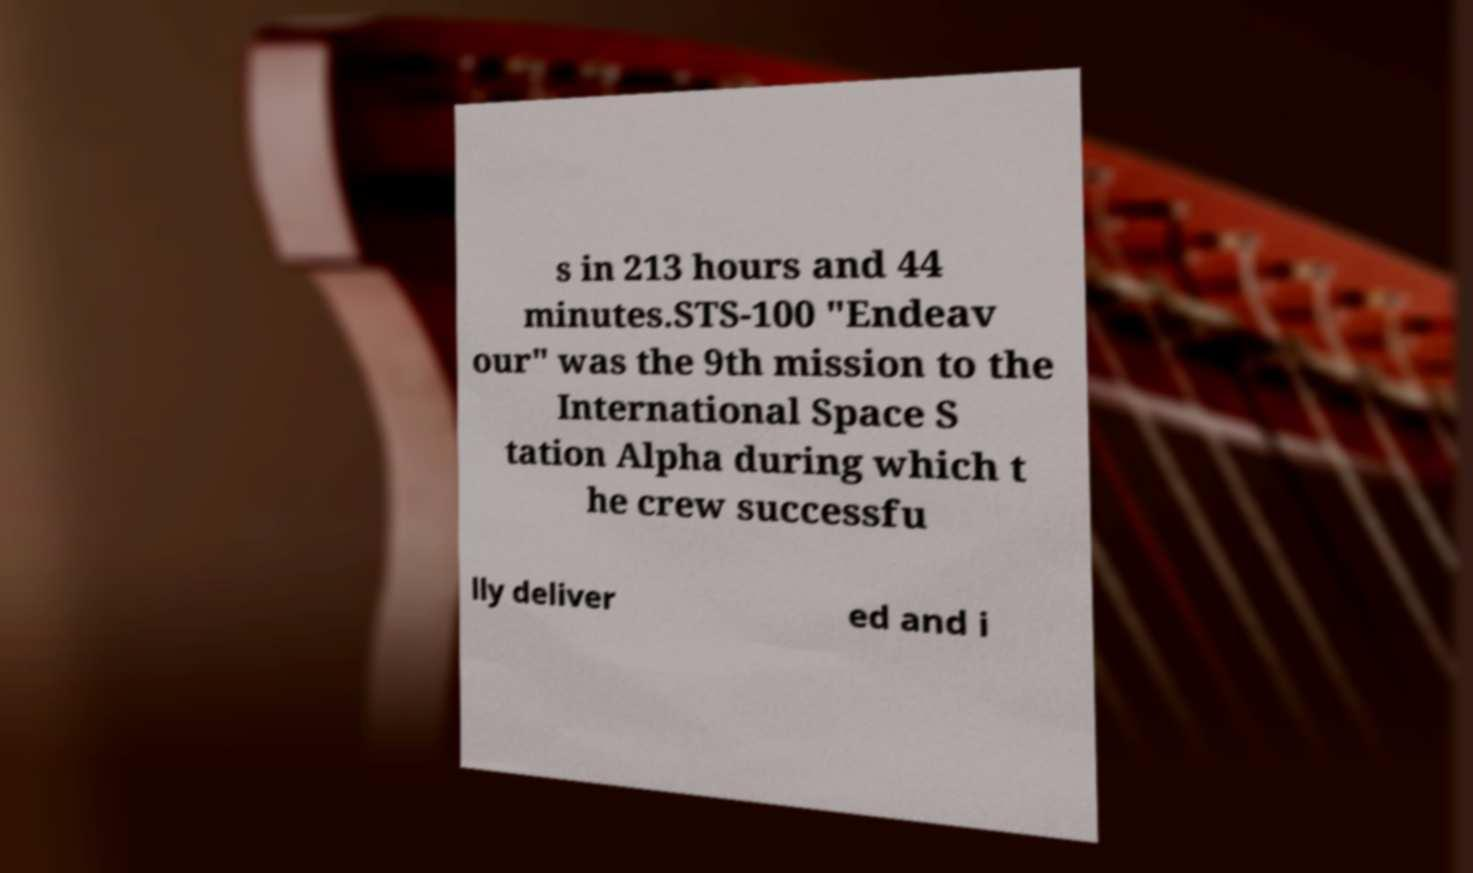What messages or text are displayed in this image? I need them in a readable, typed format. s in 213 hours and 44 minutes.STS-100 "Endeav our" was the 9th mission to the International Space S tation Alpha during which t he crew successfu lly deliver ed and i 